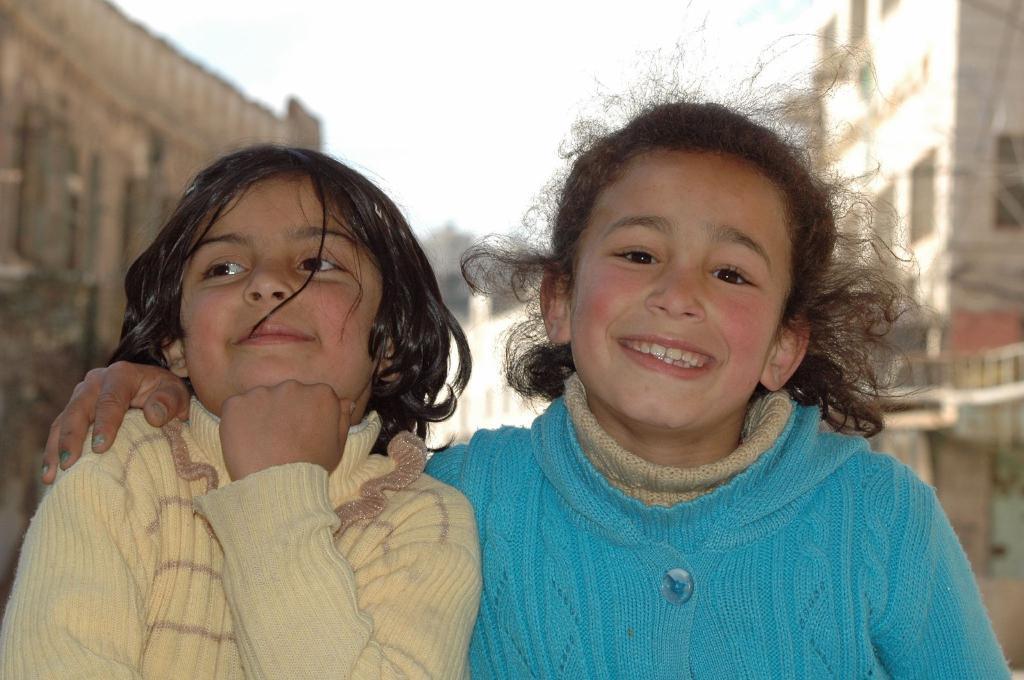In one or two sentences, can you explain what this image depicts? These two girls are smiling. Background it is blurry and we can see buildings. 